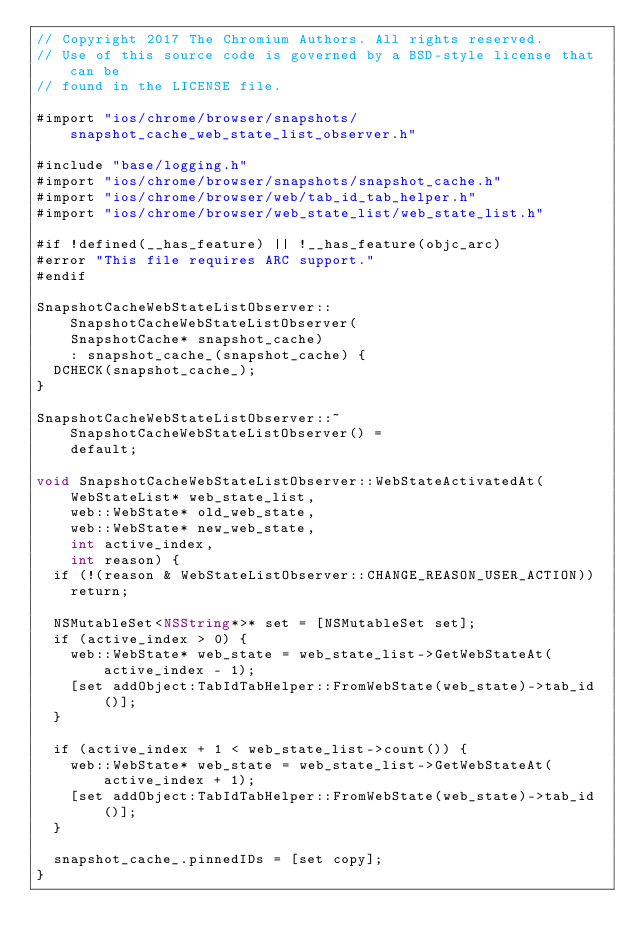Convert code to text. <code><loc_0><loc_0><loc_500><loc_500><_ObjectiveC_>// Copyright 2017 The Chromium Authors. All rights reserved.
// Use of this source code is governed by a BSD-style license that can be
// found in the LICENSE file.

#import "ios/chrome/browser/snapshots/snapshot_cache_web_state_list_observer.h"

#include "base/logging.h"
#import "ios/chrome/browser/snapshots/snapshot_cache.h"
#import "ios/chrome/browser/web/tab_id_tab_helper.h"
#import "ios/chrome/browser/web_state_list/web_state_list.h"

#if !defined(__has_feature) || !__has_feature(objc_arc)
#error "This file requires ARC support."
#endif

SnapshotCacheWebStateListObserver::SnapshotCacheWebStateListObserver(
    SnapshotCache* snapshot_cache)
    : snapshot_cache_(snapshot_cache) {
  DCHECK(snapshot_cache_);
}

SnapshotCacheWebStateListObserver::~SnapshotCacheWebStateListObserver() =
    default;

void SnapshotCacheWebStateListObserver::WebStateActivatedAt(
    WebStateList* web_state_list,
    web::WebState* old_web_state,
    web::WebState* new_web_state,
    int active_index,
    int reason) {
  if (!(reason & WebStateListObserver::CHANGE_REASON_USER_ACTION))
    return;

  NSMutableSet<NSString*>* set = [NSMutableSet set];
  if (active_index > 0) {
    web::WebState* web_state = web_state_list->GetWebStateAt(active_index - 1);
    [set addObject:TabIdTabHelper::FromWebState(web_state)->tab_id()];
  }

  if (active_index + 1 < web_state_list->count()) {
    web::WebState* web_state = web_state_list->GetWebStateAt(active_index + 1);
    [set addObject:TabIdTabHelper::FromWebState(web_state)->tab_id()];
  }

  snapshot_cache_.pinnedIDs = [set copy];
}
</code> 